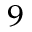<formula> <loc_0><loc_0><loc_500><loc_500>^ { 9 }</formula> 